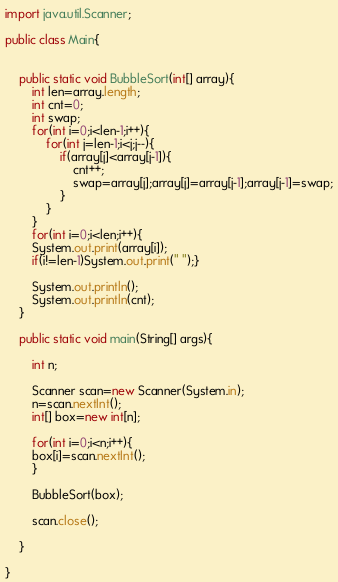<code> <loc_0><loc_0><loc_500><loc_500><_Java_>import java.util.Scanner;

public class Main{


	public static void BubbleSort(int[] array){
		int len=array.length;
		int cnt=0;
		int swap;
		for(int i=0;i<len-1;i++){
			for(int j=len-1;i<j;j--){
				if(array[j]<array[j-1]){
					cnt++;
					swap=array[j];array[j]=array[j-1];array[j-1]=swap;
				}
			}
		}
		for(int i=0;i<len;i++){
		System.out.print(array[i]);
		if(i!=len-1)System.out.print(" ");}

		System.out.println();
		System.out.println(cnt);
	}

	public static void main(String[] args){

		int n;

		Scanner scan=new Scanner(System.in);
		n=scan.nextInt();
		int[] box=new int[n];

		for(int i=0;i<n;i++){
		box[i]=scan.nextInt();
		}

		BubbleSort(box);

		scan.close();

	}

}</code> 